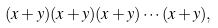Convert formula to latex. <formula><loc_0><loc_0><loc_500><loc_500>( x + y ) ( x + y ) ( x + y ) \cdots ( x + y ) ,</formula> 